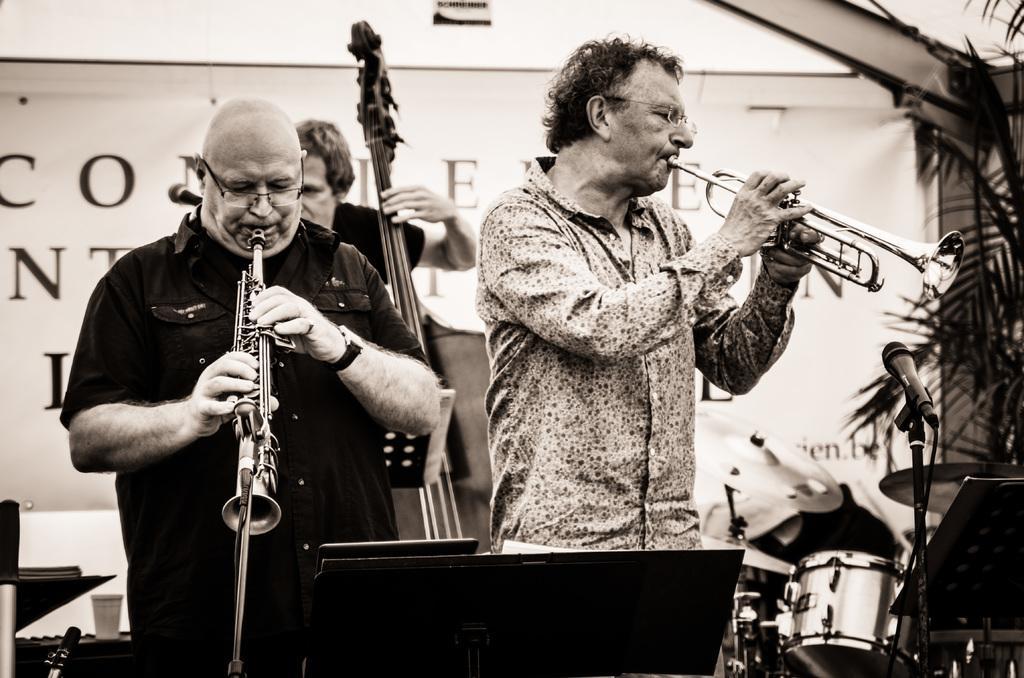Please provide a concise description of this image. In this image I can see three persons playing musical instruments. I can also see few plants, background I can see a banner and the image is in black and white. 